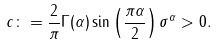Convert formula to latex. <formula><loc_0><loc_0><loc_500><loc_500>c \colon = \frac { 2 } { \pi } \Gamma ( \alpha ) \sin \left ( \frac { \pi \alpha } { 2 } \right ) \sigma ^ { \alpha } > 0 .</formula> 